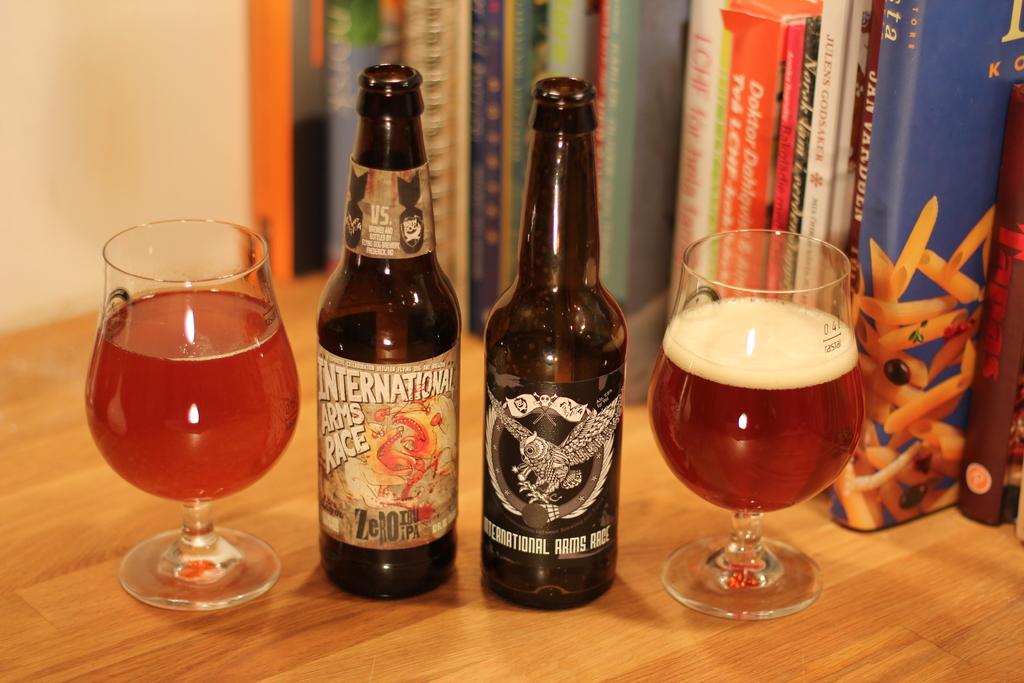What kind of drink is in the bottle?
Ensure brevity in your answer.  Beer. What race is being mentioned on the bottle to the left?
Ensure brevity in your answer.  Arms. 